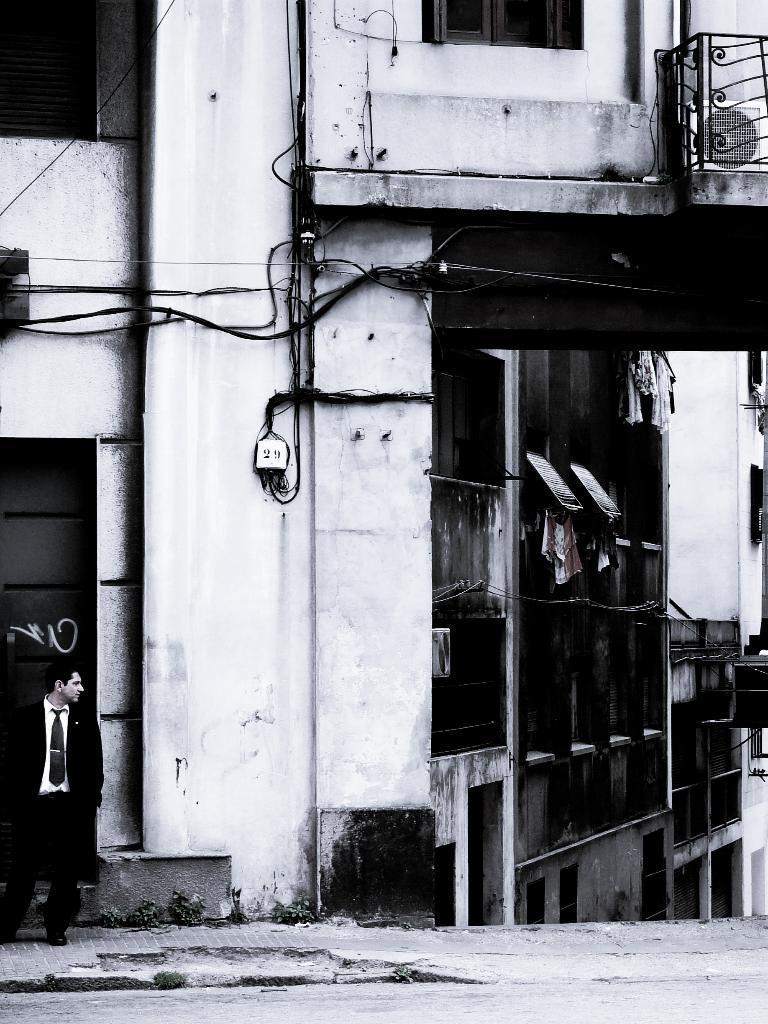Please provide a concise description of this image. In the foreground I can see a person is standing on the road, windows, buildings and wires. This image is taken during a day. 